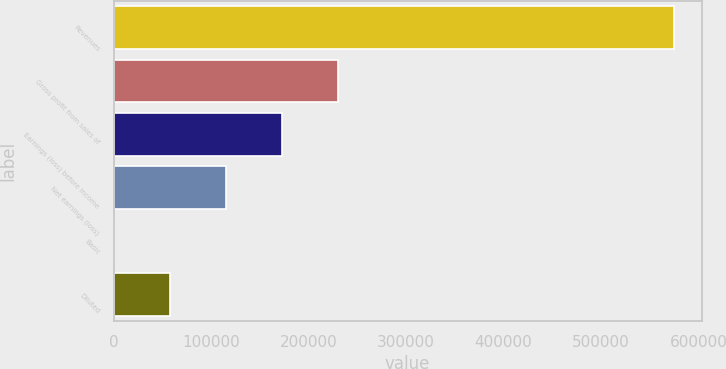<chart> <loc_0><loc_0><loc_500><loc_500><bar_chart><fcel>Revenues<fcel>Gross profit from sales of<fcel>Earnings (loss) before income<fcel>Net earnings (loss)<fcel>Basic<fcel>Diluted<nl><fcel>574442<fcel>229777<fcel>172333<fcel>114888<fcel>0.04<fcel>57444.2<nl></chart> 